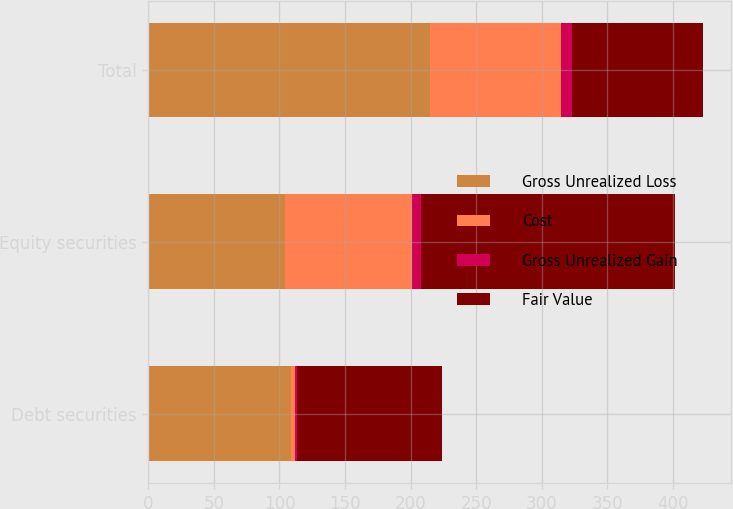<chart> <loc_0><loc_0><loc_500><loc_500><stacked_bar_chart><ecel><fcel>Debt securities<fcel>Equity securities<fcel>Total<nl><fcel>Gross Unrealized Loss<fcel>109<fcel>104<fcel>215<nl><fcel>Cost<fcel>3<fcel>97<fcel>100<nl><fcel>Gross Unrealized Gain<fcel>1<fcel>7<fcel>8<nl><fcel>Fair Value<fcel>111<fcel>194<fcel>100<nl></chart> 